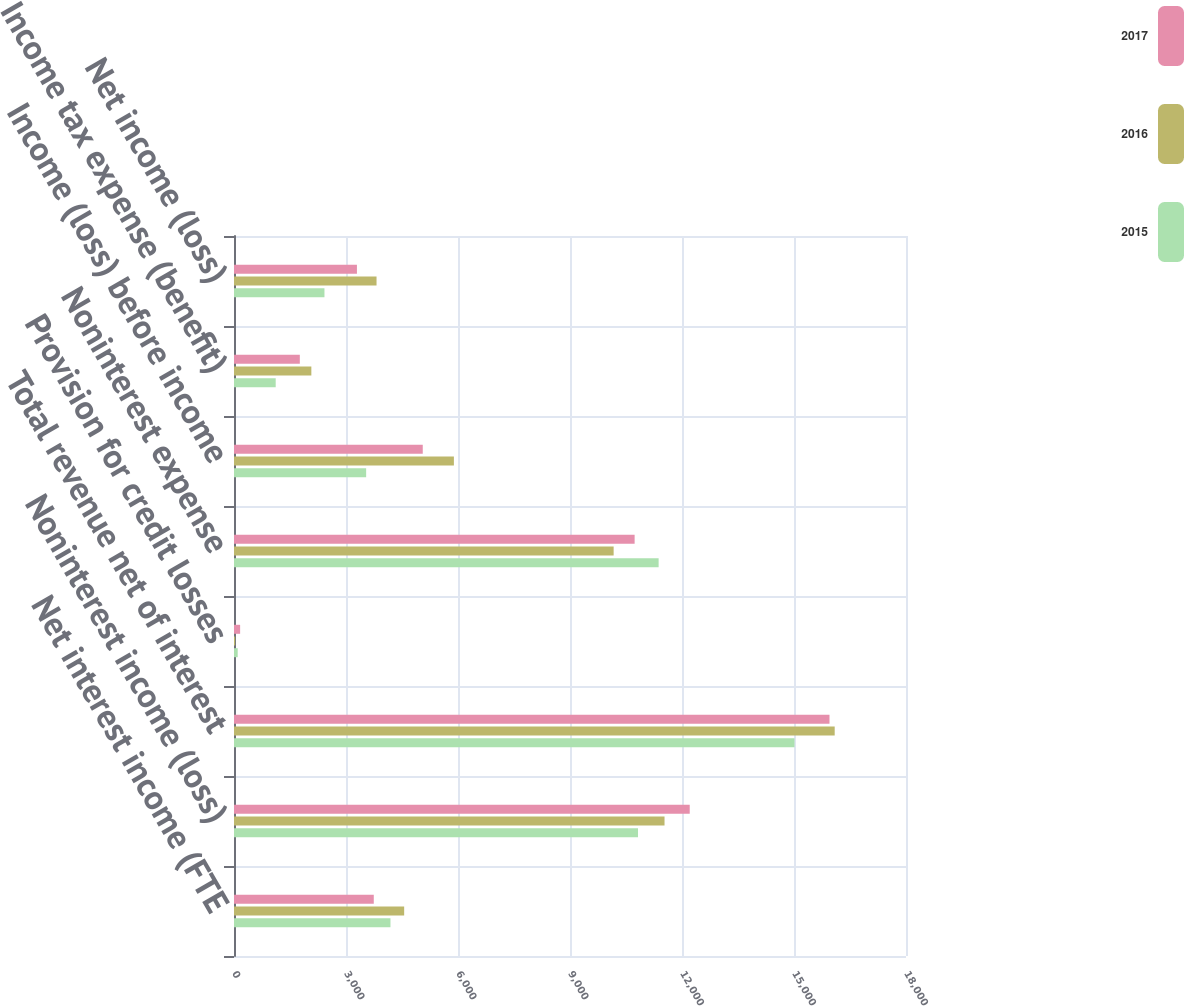<chart> <loc_0><loc_0><loc_500><loc_500><stacked_bar_chart><ecel><fcel>Net interest income (FTE<fcel>Noninterest income (loss)<fcel>Total revenue net of interest<fcel>Provision for credit losses<fcel>Noninterest expense<fcel>Income (loss) before income<fcel>Income tax expense (benefit)<fcel>Net income (loss)<nl><fcel>2017<fcel>3744<fcel>12207<fcel>15951<fcel>164<fcel>10731<fcel>5056<fcel>1763<fcel>3293<nl><fcel>2016<fcel>4558<fcel>11532<fcel>16090<fcel>31<fcel>10169<fcel>5890<fcel>2072<fcel>3818<nl><fcel>2015<fcel>4191<fcel>10822<fcel>15013<fcel>99<fcel>11374<fcel>3540<fcel>1117<fcel>2423<nl></chart> 